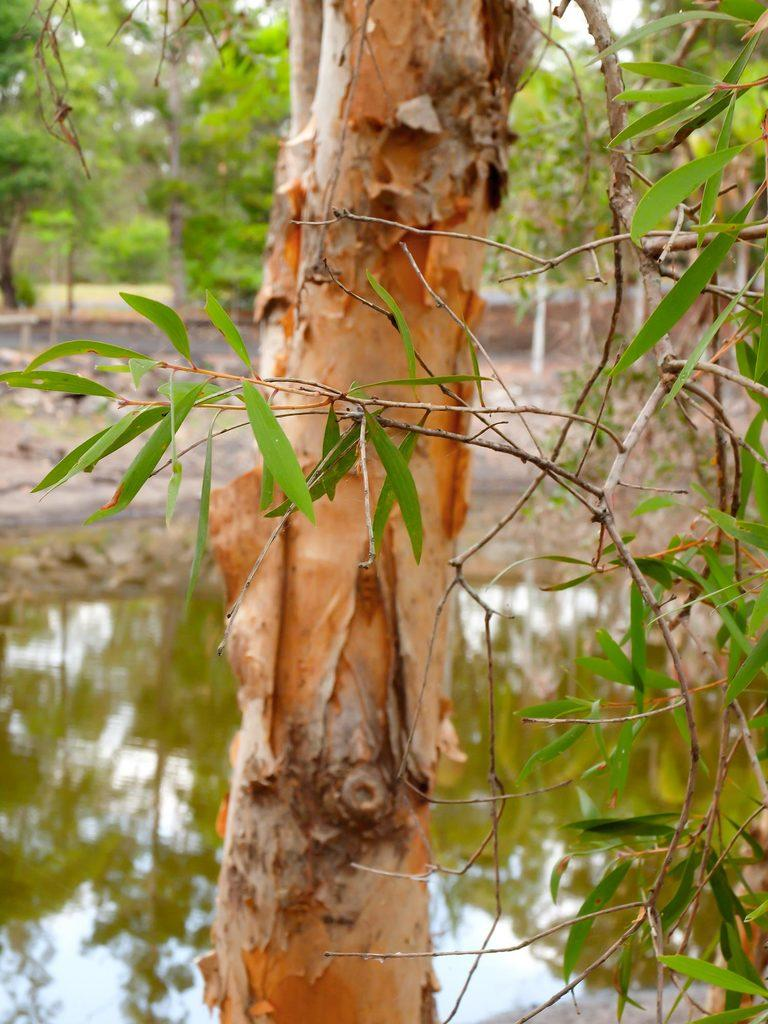What type of vegetation can be seen in the image? There are trees in the image. What natural element is visible in the image? There is water visible in the image. What type of legal advice is the lawyer providing in the image? There is no lawyer present in the image, so it is not possible to determine what legal advice might be provided. What type of camping equipment can be seen in the image? There is no camping equipment present in the image; it features trees and water. 